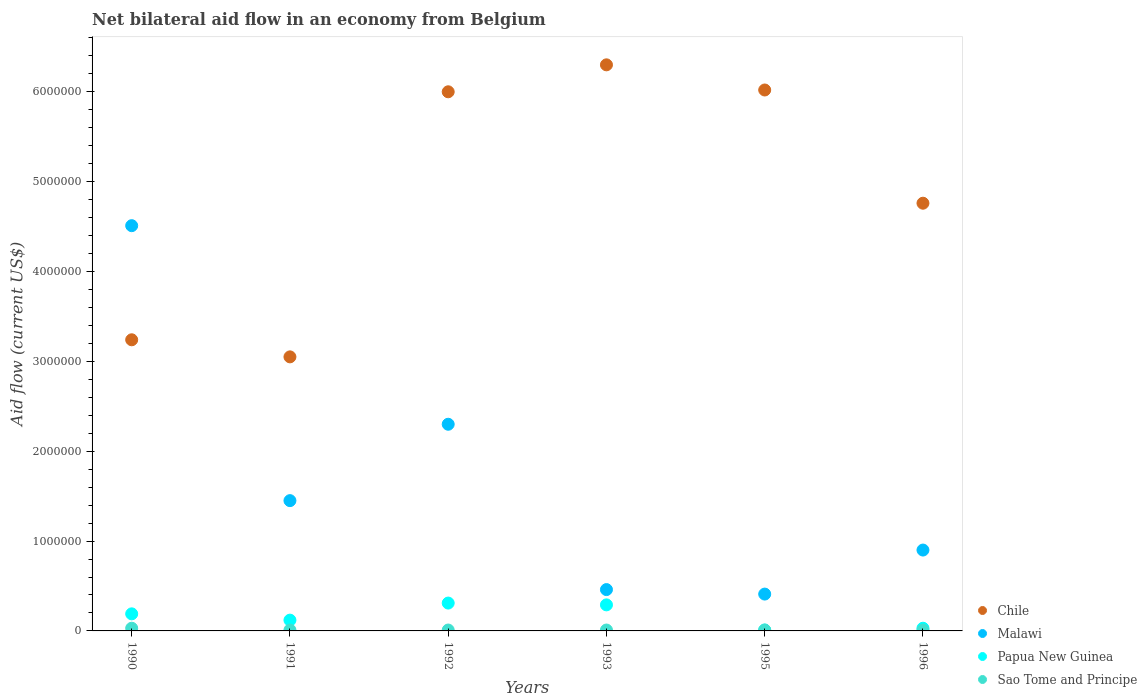Is the number of dotlines equal to the number of legend labels?
Provide a short and direct response. Yes. What is the net bilateral aid flow in Chile in 1996?
Make the answer very short. 4.76e+06. Across all years, what is the minimum net bilateral aid flow in Chile?
Your answer should be very brief. 3.05e+06. In which year was the net bilateral aid flow in Papua New Guinea minimum?
Make the answer very short. 1995. What is the total net bilateral aid flow in Malawi in the graph?
Make the answer very short. 1.00e+07. What is the difference between the net bilateral aid flow in Sao Tome and Principe in 1992 and the net bilateral aid flow in Papua New Guinea in 1995?
Your response must be concise. 0. What is the average net bilateral aid flow in Chile per year?
Your response must be concise. 4.90e+06. In the year 1992, what is the difference between the net bilateral aid flow in Papua New Guinea and net bilateral aid flow in Malawi?
Your answer should be compact. -1.99e+06. In how many years, is the net bilateral aid flow in Sao Tome and Principe greater than 400000 US$?
Offer a terse response. 0. What is the ratio of the net bilateral aid flow in Chile in 1991 to that in 1993?
Keep it short and to the point. 0.48. Is the difference between the net bilateral aid flow in Papua New Guinea in 1990 and 1995 greater than the difference between the net bilateral aid flow in Malawi in 1990 and 1995?
Keep it short and to the point. No. What is the difference between the highest and the second highest net bilateral aid flow in Sao Tome and Principe?
Ensure brevity in your answer.  2.00e+04. What is the difference between the highest and the lowest net bilateral aid flow in Chile?
Offer a terse response. 3.25e+06. Is the sum of the net bilateral aid flow in Malawi in 1995 and 1996 greater than the maximum net bilateral aid flow in Chile across all years?
Provide a succinct answer. No. Is it the case that in every year, the sum of the net bilateral aid flow in Sao Tome and Principe and net bilateral aid flow in Malawi  is greater than the net bilateral aid flow in Chile?
Make the answer very short. No. Does the net bilateral aid flow in Papua New Guinea monotonically increase over the years?
Your answer should be compact. No. Is the net bilateral aid flow in Malawi strictly less than the net bilateral aid flow in Chile over the years?
Provide a succinct answer. No. Are the values on the major ticks of Y-axis written in scientific E-notation?
Make the answer very short. No. Does the graph contain any zero values?
Keep it short and to the point. No. What is the title of the graph?
Provide a succinct answer. Net bilateral aid flow in an economy from Belgium. What is the label or title of the X-axis?
Provide a short and direct response. Years. What is the label or title of the Y-axis?
Give a very brief answer. Aid flow (current US$). What is the Aid flow (current US$) in Chile in 1990?
Your answer should be very brief. 3.24e+06. What is the Aid flow (current US$) of Malawi in 1990?
Make the answer very short. 4.51e+06. What is the Aid flow (current US$) of Papua New Guinea in 1990?
Give a very brief answer. 1.90e+05. What is the Aid flow (current US$) of Sao Tome and Principe in 1990?
Make the answer very short. 3.00e+04. What is the Aid flow (current US$) in Chile in 1991?
Your response must be concise. 3.05e+06. What is the Aid flow (current US$) of Malawi in 1991?
Your answer should be compact. 1.45e+06. What is the Aid flow (current US$) of Malawi in 1992?
Your response must be concise. 2.30e+06. What is the Aid flow (current US$) in Sao Tome and Principe in 1992?
Give a very brief answer. 10000. What is the Aid flow (current US$) in Chile in 1993?
Offer a very short reply. 6.30e+06. What is the Aid flow (current US$) of Malawi in 1993?
Your answer should be compact. 4.60e+05. What is the Aid flow (current US$) in Papua New Guinea in 1993?
Offer a very short reply. 2.90e+05. What is the Aid flow (current US$) in Sao Tome and Principe in 1993?
Ensure brevity in your answer.  10000. What is the Aid flow (current US$) in Chile in 1995?
Provide a short and direct response. 6.02e+06. What is the Aid flow (current US$) in Chile in 1996?
Your answer should be compact. 4.76e+06. What is the Aid flow (current US$) of Malawi in 1996?
Offer a terse response. 9.00e+05. What is the Aid flow (current US$) in Papua New Guinea in 1996?
Offer a very short reply. 3.00e+04. What is the Aid flow (current US$) in Sao Tome and Principe in 1996?
Your response must be concise. 10000. Across all years, what is the maximum Aid flow (current US$) in Chile?
Offer a terse response. 6.30e+06. Across all years, what is the maximum Aid flow (current US$) in Malawi?
Provide a succinct answer. 4.51e+06. Across all years, what is the maximum Aid flow (current US$) in Papua New Guinea?
Your answer should be very brief. 3.10e+05. Across all years, what is the maximum Aid flow (current US$) of Sao Tome and Principe?
Offer a terse response. 3.00e+04. Across all years, what is the minimum Aid flow (current US$) in Chile?
Your response must be concise. 3.05e+06. Across all years, what is the minimum Aid flow (current US$) in Malawi?
Make the answer very short. 4.10e+05. Across all years, what is the minimum Aid flow (current US$) in Papua New Guinea?
Give a very brief answer. 10000. Across all years, what is the minimum Aid flow (current US$) of Sao Tome and Principe?
Your response must be concise. 10000. What is the total Aid flow (current US$) in Chile in the graph?
Offer a terse response. 2.94e+07. What is the total Aid flow (current US$) of Malawi in the graph?
Your response must be concise. 1.00e+07. What is the total Aid flow (current US$) in Papua New Guinea in the graph?
Ensure brevity in your answer.  9.50e+05. What is the difference between the Aid flow (current US$) in Malawi in 1990 and that in 1991?
Provide a succinct answer. 3.06e+06. What is the difference between the Aid flow (current US$) in Chile in 1990 and that in 1992?
Your response must be concise. -2.76e+06. What is the difference between the Aid flow (current US$) in Malawi in 1990 and that in 1992?
Your response must be concise. 2.21e+06. What is the difference between the Aid flow (current US$) in Chile in 1990 and that in 1993?
Your answer should be compact. -3.06e+06. What is the difference between the Aid flow (current US$) in Malawi in 1990 and that in 1993?
Provide a short and direct response. 4.05e+06. What is the difference between the Aid flow (current US$) of Sao Tome and Principe in 1990 and that in 1993?
Make the answer very short. 2.00e+04. What is the difference between the Aid flow (current US$) of Chile in 1990 and that in 1995?
Your answer should be very brief. -2.78e+06. What is the difference between the Aid flow (current US$) of Malawi in 1990 and that in 1995?
Your response must be concise. 4.10e+06. What is the difference between the Aid flow (current US$) of Papua New Guinea in 1990 and that in 1995?
Your response must be concise. 1.80e+05. What is the difference between the Aid flow (current US$) in Sao Tome and Principe in 1990 and that in 1995?
Your answer should be very brief. 2.00e+04. What is the difference between the Aid flow (current US$) of Chile in 1990 and that in 1996?
Your answer should be compact. -1.52e+06. What is the difference between the Aid flow (current US$) in Malawi in 1990 and that in 1996?
Your answer should be compact. 3.61e+06. What is the difference between the Aid flow (current US$) in Papua New Guinea in 1990 and that in 1996?
Your response must be concise. 1.60e+05. What is the difference between the Aid flow (current US$) in Sao Tome and Principe in 1990 and that in 1996?
Offer a terse response. 2.00e+04. What is the difference between the Aid flow (current US$) in Chile in 1991 and that in 1992?
Offer a very short reply. -2.95e+06. What is the difference between the Aid flow (current US$) in Malawi in 1991 and that in 1992?
Offer a terse response. -8.50e+05. What is the difference between the Aid flow (current US$) in Papua New Guinea in 1991 and that in 1992?
Keep it short and to the point. -1.90e+05. What is the difference between the Aid flow (current US$) in Sao Tome and Principe in 1991 and that in 1992?
Make the answer very short. 0. What is the difference between the Aid flow (current US$) in Chile in 1991 and that in 1993?
Give a very brief answer. -3.25e+06. What is the difference between the Aid flow (current US$) in Malawi in 1991 and that in 1993?
Offer a terse response. 9.90e+05. What is the difference between the Aid flow (current US$) in Chile in 1991 and that in 1995?
Keep it short and to the point. -2.97e+06. What is the difference between the Aid flow (current US$) of Malawi in 1991 and that in 1995?
Provide a short and direct response. 1.04e+06. What is the difference between the Aid flow (current US$) of Papua New Guinea in 1991 and that in 1995?
Give a very brief answer. 1.10e+05. What is the difference between the Aid flow (current US$) in Sao Tome and Principe in 1991 and that in 1995?
Give a very brief answer. 0. What is the difference between the Aid flow (current US$) in Chile in 1991 and that in 1996?
Make the answer very short. -1.71e+06. What is the difference between the Aid flow (current US$) in Malawi in 1991 and that in 1996?
Make the answer very short. 5.50e+05. What is the difference between the Aid flow (current US$) of Papua New Guinea in 1991 and that in 1996?
Give a very brief answer. 9.00e+04. What is the difference between the Aid flow (current US$) of Sao Tome and Principe in 1991 and that in 1996?
Your answer should be compact. 0. What is the difference between the Aid flow (current US$) of Chile in 1992 and that in 1993?
Provide a short and direct response. -3.00e+05. What is the difference between the Aid flow (current US$) in Malawi in 1992 and that in 1993?
Offer a very short reply. 1.84e+06. What is the difference between the Aid flow (current US$) in Papua New Guinea in 1992 and that in 1993?
Offer a terse response. 2.00e+04. What is the difference between the Aid flow (current US$) of Sao Tome and Principe in 1992 and that in 1993?
Give a very brief answer. 0. What is the difference between the Aid flow (current US$) of Malawi in 1992 and that in 1995?
Give a very brief answer. 1.89e+06. What is the difference between the Aid flow (current US$) of Sao Tome and Principe in 1992 and that in 1995?
Your answer should be very brief. 0. What is the difference between the Aid flow (current US$) in Chile in 1992 and that in 1996?
Offer a very short reply. 1.24e+06. What is the difference between the Aid flow (current US$) of Malawi in 1992 and that in 1996?
Provide a succinct answer. 1.40e+06. What is the difference between the Aid flow (current US$) in Sao Tome and Principe in 1992 and that in 1996?
Keep it short and to the point. 0. What is the difference between the Aid flow (current US$) in Chile in 1993 and that in 1996?
Your answer should be compact. 1.54e+06. What is the difference between the Aid flow (current US$) in Malawi in 1993 and that in 1996?
Offer a very short reply. -4.40e+05. What is the difference between the Aid flow (current US$) in Chile in 1995 and that in 1996?
Provide a short and direct response. 1.26e+06. What is the difference between the Aid flow (current US$) of Malawi in 1995 and that in 1996?
Give a very brief answer. -4.90e+05. What is the difference between the Aid flow (current US$) of Sao Tome and Principe in 1995 and that in 1996?
Keep it short and to the point. 0. What is the difference between the Aid flow (current US$) in Chile in 1990 and the Aid flow (current US$) in Malawi in 1991?
Make the answer very short. 1.79e+06. What is the difference between the Aid flow (current US$) in Chile in 1990 and the Aid flow (current US$) in Papua New Guinea in 1991?
Make the answer very short. 3.12e+06. What is the difference between the Aid flow (current US$) in Chile in 1990 and the Aid flow (current US$) in Sao Tome and Principe in 1991?
Offer a terse response. 3.23e+06. What is the difference between the Aid flow (current US$) of Malawi in 1990 and the Aid flow (current US$) of Papua New Guinea in 1991?
Offer a very short reply. 4.39e+06. What is the difference between the Aid flow (current US$) in Malawi in 1990 and the Aid flow (current US$) in Sao Tome and Principe in 1991?
Give a very brief answer. 4.50e+06. What is the difference between the Aid flow (current US$) in Chile in 1990 and the Aid flow (current US$) in Malawi in 1992?
Offer a terse response. 9.40e+05. What is the difference between the Aid flow (current US$) in Chile in 1990 and the Aid flow (current US$) in Papua New Guinea in 1992?
Make the answer very short. 2.93e+06. What is the difference between the Aid flow (current US$) in Chile in 1990 and the Aid flow (current US$) in Sao Tome and Principe in 1992?
Provide a succinct answer. 3.23e+06. What is the difference between the Aid flow (current US$) in Malawi in 1990 and the Aid flow (current US$) in Papua New Guinea in 1992?
Provide a short and direct response. 4.20e+06. What is the difference between the Aid flow (current US$) in Malawi in 1990 and the Aid flow (current US$) in Sao Tome and Principe in 1992?
Ensure brevity in your answer.  4.50e+06. What is the difference between the Aid flow (current US$) of Papua New Guinea in 1990 and the Aid flow (current US$) of Sao Tome and Principe in 1992?
Provide a short and direct response. 1.80e+05. What is the difference between the Aid flow (current US$) in Chile in 1990 and the Aid flow (current US$) in Malawi in 1993?
Offer a very short reply. 2.78e+06. What is the difference between the Aid flow (current US$) of Chile in 1990 and the Aid flow (current US$) of Papua New Guinea in 1993?
Offer a terse response. 2.95e+06. What is the difference between the Aid flow (current US$) of Chile in 1990 and the Aid flow (current US$) of Sao Tome and Principe in 1993?
Keep it short and to the point. 3.23e+06. What is the difference between the Aid flow (current US$) in Malawi in 1990 and the Aid flow (current US$) in Papua New Guinea in 1993?
Your answer should be very brief. 4.22e+06. What is the difference between the Aid flow (current US$) in Malawi in 1990 and the Aid flow (current US$) in Sao Tome and Principe in 1993?
Your answer should be very brief. 4.50e+06. What is the difference between the Aid flow (current US$) of Papua New Guinea in 1990 and the Aid flow (current US$) of Sao Tome and Principe in 1993?
Ensure brevity in your answer.  1.80e+05. What is the difference between the Aid flow (current US$) of Chile in 1990 and the Aid flow (current US$) of Malawi in 1995?
Your response must be concise. 2.83e+06. What is the difference between the Aid flow (current US$) of Chile in 1990 and the Aid flow (current US$) of Papua New Guinea in 1995?
Make the answer very short. 3.23e+06. What is the difference between the Aid flow (current US$) of Chile in 1990 and the Aid flow (current US$) of Sao Tome and Principe in 1995?
Make the answer very short. 3.23e+06. What is the difference between the Aid flow (current US$) of Malawi in 1990 and the Aid flow (current US$) of Papua New Guinea in 1995?
Ensure brevity in your answer.  4.50e+06. What is the difference between the Aid flow (current US$) of Malawi in 1990 and the Aid flow (current US$) of Sao Tome and Principe in 1995?
Keep it short and to the point. 4.50e+06. What is the difference between the Aid flow (current US$) of Papua New Guinea in 1990 and the Aid flow (current US$) of Sao Tome and Principe in 1995?
Give a very brief answer. 1.80e+05. What is the difference between the Aid flow (current US$) of Chile in 1990 and the Aid flow (current US$) of Malawi in 1996?
Give a very brief answer. 2.34e+06. What is the difference between the Aid flow (current US$) of Chile in 1990 and the Aid flow (current US$) of Papua New Guinea in 1996?
Offer a very short reply. 3.21e+06. What is the difference between the Aid flow (current US$) in Chile in 1990 and the Aid flow (current US$) in Sao Tome and Principe in 1996?
Keep it short and to the point. 3.23e+06. What is the difference between the Aid flow (current US$) in Malawi in 1990 and the Aid flow (current US$) in Papua New Guinea in 1996?
Keep it short and to the point. 4.48e+06. What is the difference between the Aid flow (current US$) of Malawi in 1990 and the Aid flow (current US$) of Sao Tome and Principe in 1996?
Make the answer very short. 4.50e+06. What is the difference between the Aid flow (current US$) of Papua New Guinea in 1990 and the Aid flow (current US$) of Sao Tome and Principe in 1996?
Your answer should be compact. 1.80e+05. What is the difference between the Aid flow (current US$) of Chile in 1991 and the Aid flow (current US$) of Malawi in 1992?
Keep it short and to the point. 7.50e+05. What is the difference between the Aid flow (current US$) of Chile in 1991 and the Aid flow (current US$) of Papua New Guinea in 1992?
Your answer should be compact. 2.74e+06. What is the difference between the Aid flow (current US$) of Chile in 1991 and the Aid flow (current US$) of Sao Tome and Principe in 1992?
Your response must be concise. 3.04e+06. What is the difference between the Aid flow (current US$) of Malawi in 1991 and the Aid flow (current US$) of Papua New Guinea in 1992?
Your answer should be compact. 1.14e+06. What is the difference between the Aid flow (current US$) in Malawi in 1991 and the Aid flow (current US$) in Sao Tome and Principe in 1992?
Offer a very short reply. 1.44e+06. What is the difference between the Aid flow (current US$) of Chile in 1991 and the Aid flow (current US$) of Malawi in 1993?
Ensure brevity in your answer.  2.59e+06. What is the difference between the Aid flow (current US$) in Chile in 1991 and the Aid flow (current US$) in Papua New Guinea in 1993?
Your response must be concise. 2.76e+06. What is the difference between the Aid flow (current US$) of Chile in 1991 and the Aid flow (current US$) of Sao Tome and Principe in 1993?
Keep it short and to the point. 3.04e+06. What is the difference between the Aid flow (current US$) in Malawi in 1991 and the Aid flow (current US$) in Papua New Guinea in 1993?
Provide a short and direct response. 1.16e+06. What is the difference between the Aid flow (current US$) of Malawi in 1991 and the Aid flow (current US$) of Sao Tome and Principe in 1993?
Provide a succinct answer. 1.44e+06. What is the difference between the Aid flow (current US$) of Chile in 1991 and the Aid flow (current US$) of Malawi in 1995?
Ensure brevity in your answer.  2.64e+06. What is the difference between the Aid flow (current US$) of Chile in 1991 and the Aid flow (current US$) of Papua New Guinea in 1995?
Offer a terse response. 3.04e+06. What is the difference between the Aid flow (current US$) in Chile in 1991 and the Aid flow (current US$) in Sao Tome and Principe in 1995?
Offer a terse response. 3.04e+06. What is the difference between the Aid flow (current US$) in Malawi in 1991 and the Aid flow (current US$) in Papua New Guinea in 1995?
Give a very brief answer. 1.44e+06. What is the difference between the Aid flow (current US$) of Malawi in 1991 and the Aid flow (current US$) of Sao Tome and Principe in 1995?
Your answer should be compact. 1.44e+06. What is the difference between the Aid flow (current US$) in Papua New Guinea in 1991 and the Aid flow (current US$) in Sao Tome and Principe in 1995?
Ensure brevity in your answer.  1.10e+05. What is the difference between the Aid flow (current US$) in Chile in 1991 and the Aid flow (current US$) in Malawi in 1996?
Offer a terse response. 2.15e+06. What is the difference between the Aid flow (current US$) in Chile in 1991 and the Aid flow (current US$) in Papua New Guinea in 1996?
Offer a terse response. 3.02e+06. What is the difference between the Aid flow (current US$) in Chile in 1991 and the Aid flow (current US$) in Sao Tome and Principe in 1996?
Offer a very short reply. 3.04e+06. What is the difference between the Aid flow (current US$) of Malawi in 1991 and the Aid flow (current US$) of Papua New Guinea in 1996?
Your response must be concise. 1.42e+06. What is the difference between the Aid flow (current US$) in Malawi in 1991 and the Aid flow (current US$) in Sao Tome and Principe in 1996?
Your answer should be compact. 1.44e+06. What is the difference between the Aid flow (current US$) in Papua New Guinea in 1991 and the Aid flow (current US$) in Sao Tome and Principe in 1996?
Provide a succinct answer. 1.10e+05. What is the difference between the Aid flow (current US$) in Chile in 1992 and the Aid flow (current US$) in Malawi in 1993?
Give a very brief answer. 5.54e+06. What is the difference between the Aid flow (current US$) of Chile in 1992 and the Aid flow (current US$) of Papua New Guinea in 1993?
Make the answer very short. 5.71e+06. What is the difference between the Aid flow (current US$) in Chile in 1992 and the Aid flow (current US$) in Sao Tome and Principe in 1993?
Give a very brief answer. 5.99e+06. What is the difference between the Aid flow (current US$) of Malawi in 1992 and the Aid flow (current US$) of Papua New Guinea in 1993?
Your answer should be very brief. 2.01e+06. What is the difference between the Aid flow (current US$) of Malawi in 1992 and the Aid flow (current US$) of Sao Tome and Principe in 1993?
Your answer should be very brief. 2.29e+06. What is the difference between the Aid flow (current US$) in Chile in 1992 and the Aid flow (current US$) in Malawi in 1995?
Your answer should be very brief. 5.59e+06. What is the difference between the Aid flow (current US$) of Chile in 1992 and the Aid flow (current US$) of Papua New Guinea in 1995?
Your answer should be compact. 5.99e+06. What is the difference between the Aid flow (current US$) of Chile in 1992 and the Aid flow (current US$) of Sao Tome and Principe in 1995?
Offer a terse response. 5.99e+06. What is the difference between the Aid flow (current US$) of Malawi in 1992 and the Aid flow (current US$) of Papua New Guinea in 1995?
Ensure brevity in your answer.  2.29e+06. What is the difference between the Aid flow (current US$) in Malawi in 1992 and the Aid flow (current US$) in Sao Tome and Principe in 1995?
Make the answer very short. 2.29e+06. What is the difference between the Aid flow (current US$) in Papua New Guinea in 1992 and the Aid flow (current US$) in Sao Tome and Principe in 1995?
Offer a terse response. 3.00e+05. What is the difference between the Aid flow (current US$) in Chile in 1992 and the Aid flow (current US$) in Malawi in 1996?
Provide a succinct answer. 5.10e+06. What is the difference between the Aid flow (current US$) in Chile in 1992 and the Aid flow (current US$) in Papua New Guinea in 1996?
Keep it short and to the point. 5.97e+06. What is the difference between the Aid flow (current US$) of Chile in 1992 and the Aid flow (current US$) of Sao Tome and Principe in 1996?
Give a very brief answer. 5.99e+06. What is the difference between the Aid flow (current US$) of Malawi in 1992 and the Aid flow (current US$) of Papua New Guinea in 1996?
Make the answer very short. 2.27e+06. What is the difference between the Aid flow (current US$) in Malawi in 1992 and the Aid flow (current US$) in Sao Tome and Principe in 1996?
Your answer should be compact. 2.29e+06. What is the difference between the Aid flow (current US$) in Chile in 1993 and the Aid flow (current US$) in Malawi in 1995?
Offer a terse response. 5.89e+06. What is the difference between the Aid flow (current US$) in Chile in 1993 and the Aid flow (current US$) in Papua New Guinea in 1995?
Make the answer very short. 6.29e+06. What is the difference between the Aid flow (current US$) of Chile in 1993 and the Aid flow (current US$) of Sao Tome and Principe in 1995?
Ensure brevity in your answer.  6.29e+06. What is the difference between the Aid flow (current US$) of Papua New Guinea in 1993 and the Aid flow (current US$) of Sao Tome and Principe in 1995?
Your response must be concise. 2.80e+05. What is the difference between the Aid flow (current US$) in Chile in 1993 and the Aid flow (current US$) in Malawi in 1996?
Make the answer very short. 5.40e+06. What is the difference between the Aid flow (current US$) in Chile in 1993 and the Aid flow (current US$) in Papua New Guinea in 1996?
Give a very brief answer. 6.27e+06. What is the difference between the Aid flow (current US$) in Chile in 1993 and the Aid flow (current US$) in Sao Tome and Principe in 1996?
Ensure brevity in your answer.  6.29e+06. What is the difference between the Aid flow (current US$) in Malawi in 1993 and the Aid flow (current US$) in Papua New Guinea in 1996?
Keep it short and to the point. 4.30e+05. What is the difference between the Aid flow (current US$) in Malawi in 1993 and the Aid flow (current US$) in Sao Tome and Principe in 1996?
Ensure brevity in your answer.  4.50e+05. What is the difference between the Aid flow (current US$) of Papua New Guinea in 1993 and the Aid flow (current US$) of Sao Tome and Principe in 1996?
Your response must be concise. 2.80e+05. What is the difference between the Aid flow (current US$) of Chile in 1995 and the Aid flow (current US$) of Malawi in 1996?
Ensure brevity in your answer.  5.12e+06. What is the difference between the Aid flow (current US$) of Chile in 1995 and the Aid flow (current US$) of Papua New Guinea in 1996?
Ensure brevity in your answer.  5.99e+06. What is the difference between the Aid flow (current US$) of Chile in 1995 and the Aid flow (current US$) of Sao Tome and Principe in 1996?
Your answer should be very brief. 6.01e+06. What is the difference between the Aid flow (current US$) of Malawi in 1995 and the Aid flow (current US$) of Papua New Guinea in 1996?
Give a very brief answer. 3.80e+05. What is the difference between the Aid flow (current US$) of Malawi in 1995 and the Aid flow (current US$) of Sao Tome and Principe in 1996?
Offer a very short reply. 4.00e+05. What is the difference between the Aid flow (current US$) of Papua New Guinea in 1995 and the Aid flow (current US$) of Sao Tome and Principe in 1996?
Offer a very short reply. 0. What is the average Aid flow (current US$) of Chile per year?
Offer a very short reply. 4.90e+06. What is the average Aid flow (current US$) in Malawi per year?
Provide a succinct answer. 1.67e+06. What is the average Aid flow (current US$) in Papua New Guinea per year?
Give a very brief answer. 1.58e+05. What is the average Aid flow (current US$) of Sao Tome and Principe per year?
Offer a terse response. 1.33e+04. In the year 1990, what is the difference between the Aid flow (current US$) of Chile and Aid flow (current US$) of Malawi?
Your answer should be very brief. -1.27e+06. In the year 1990, what is the difference between the Aid flow (current US$) of Chile and Aid flow (current US$) of Papua New Guinea?
Provide a short and direct response. 3.05e+06. In the year 1990, what is the difference between the Aid flow (current US$) in Chile and Aid flow (current US$) in Sao Tome and Principe?
Give a very brief answer. 3.21e+06. In the year 1990, what is the difference between the Aid flow (current US$) of Malawi and Aid flow (current US$) of Papua New Guinea?
Make the answer very short. 4.32e+06. In the year 1990, what is the difference between the Aid flow (current US$) in Malawi and Aid flow (current US$) in Sao Tome and Principe?
Offer a very short reply. 4.48e+06. In the year 1990, what is the difference between the Aid flow (current US$) of Papua New Guinea and Aid flow (current US$) of Sao Tome and Principe?
Provide a succinct answer. 1.60e+05. In the year 1991, what is the difference between the Aid flow (current US$) in Chile and Aid flow (current US$) in Malawi?
Your answer should be very brief. 1.60e+06. In the year 1991, what is the difference between the Aid flow (current US$) in Chile and Aid flow (current US$) in Papua New Guinea?
Your answer should be compact. 2.93e+06. In the year 1991, what is the difference between the Aid flow (current US$) of Chile and Aid flow (current US$) of Sao Tome and Principe?
Keep it short and to the point. 3.04e+06. In the year 1991, what is the difference between the Aid flow (current US$) of Malawi and Aid flow (current US$) of Papua New Guinea?
Ensure brevity in your answer.  1.33e+06. In the year 1991, what is the difference between the Aid flow (current US$) of Malawi and Aid flow (current US$) of Sao Tome and Principe?
Offer a terse response. 1.44e+06. In the year 1991, what is the difference between the Aid flow (current US$) of Papua New Guinea and Aid flow (current US$) of Sao Tome and Principe?
Your answer should be compact. 1.10e+05. In the year 1992, what is the difference between the Aid flow (current US$) in Chile and Aid flow (current US$) in Malawi?
Provide a succinct answer. 3.70e+06. In the year 1992, what is the difference between the Aid flow (current US$) in Chile and Aid flow (current US$) in Papua New Guinea?
Provide a short and direct response. 5.69e+06. In the year 1992, what is the difference between the Aid flow (current US$) in Chile and Aid flow (current US$) in Sao Tome and Principe?
Your answer should be very brief. 5.99e+06. In the year 1992, what is the difference between the Aid flow (current US$) of Malawi and Aid flow (current US$) of Papua New Guinea?
Your answer should be compact. 1.99e+06. In the year 1992, what is the difference between the Aid flow (current US$) in Malawi and Aid flow (current US$) in Sao Tome and Principe?
Provide a succinct answer. 2.29e+06. In the year 1992, what is the difference between the Aid flow (current US$) of Papua New Guinea and Aid flow (current US$) of Sao Tome and Principe?
Your answer should be compact. 3.00e+05. In the year 1993, what is the difference between the Aid flow (current US$) of Chile and Aid flow (current US$) of Malawi?
Provide a short and direct response. 5.84e+06. In the year 1993, what is the difference between the Aid flow (current US$) in Chile and Aid flow (current US$) in Papua New Guinea?
Offer a very short reply. 6.01e+06. In the year 1993, what is the difference between the Aid flow (current US$) of Chile and Aid flow (current US$) of Sao Tome and Principe?
Provide a short and direct response. 6.29e+06. In the year 1993, what is the difference between the Aid flow (current US$) of Papua New Guinea and Aid flow (current US$) of Sao Tome and Principe?
Make the answer very short. 2.80e+05. In the year 1995, what is the difference between the Aid flow (current US$) in Chile and Aid flow (current US$) in Malawi?
Offer a terse response. 5.61e+06. In the year 1995, what is the difference between the Aid flow (current US$) of Chile and Aid flow (current US$) of Papua New Guinea?
Provide a succinct answer. 6.01e+06. In the year 1995, what is the difference between the Aid flow (current US$) of Chile and Aid flow (current US$) of Sao Tome and Principe?
Your answer should be compact. 6.01e+06. In the year 1995, what is the difference between the Aid flow (current US$) in Malawi and Aid flow (current US$) in Papua New Guinea?
Ensure brevity in your answer.  4.00e+05. In the year 1995, what is the difference between the Aid flow (current US$) in Malawi and Aid flow (current US$) in Sao Tome and Principe?
Offer a terse response. 4.00e+05. In the year 1996, what is the difference between the Aid flow (current US$) of Chile and Aid flow (current US$) of Malawi?
Keep it short and to the point. 3.86e+06. In the year 1996, what is the difference between the Aid flow (current US$) of Chile and Aid flow (current US$) of Papua New Guinea?
Give a very brief answer. 4.73e+06. In the year 1996, what is the difference between the Aid flow (current US$) in Chile and Aid flow (current US$) in Sao Tome and Principe?
Your answer should be very brief. 4.75e+06. In the year 1996, what is the difference between the Aid flow (current US$) of Malawi and Aid flow (current US$) of Papua New Guinea?
Give a very brief answer. 8.70e+05. In the year 1996, what is the difference between the Aid flow (current US$) of Malawi and Aid flow (current US$) of Sao Tome and Principe?
Your answer should be very brief. 8.90e+05. What is the ratio of the Aid flow (current US$) in Chile in 1990 to that in 1991?
Your response must be concise. 1.06. What is the ratio of the Aid flow (current US$) of Malawi in 1990 to that in 1991?
Your answer should be very brief. 3.11. What is the ratio of the Aid flow (current US$) in Papua New Guinea in 1990 to that in 1991?
Offer a very short reply. 1.58. What is the ratio of the Aid flow (current US$) in Sao Tome and Principe in 1990 to that in 1991?
Provide a succinct answer. 3. What is the ratio of the Aid flow (current US$) in Chile in 1990 to that in 1992?
Offer a very short reply. 0.54. What is the ratio of the Aid flow (current US$) in Malawi in 1990 to that in 1992?
Keep it short and to the point. 1.96. What is the ratio of the Aid flow (current US$) of Papua New Guinea in 1990 to that in 1992?
Your answer should be compact. 0.61. What is the ratio of the Aid flow (current US$) of Sao Tome and Principe in 1990 to that in 1992?
Your response must be concise. 3. What is the ratio of the Aid flow (current US$) of Chile in 1990 to that in 1993?
Offer a terse response. 0.51. What is the ratio of the Aid flow (current US$) in Malawi in 1990 to that in 1993?
Your response must be concise. 9.8. What is the ratio of the Aid flow (current US$) in Papua New Guinea in 1990 to that in 1993?
Ensure brevity in your answer.  0.66. What is the ratio of the Aid flow (current US$) of Sao Tome and Principe in 1990 to that in 1993?
Keep it short and to the point. 3. What is the ratio of the Aid flow (current US$) of Chile in 1990 to that in 1995?
Provide a short and direct response. 0.54. What is the ratio of the Aid flow (current US$) in Malawi in 1990 to that in 1995?
Offer a very short reply. 11. What is the ratio of the Aid flow (current US$) in Papua New Guinea in 1990 to that in 1995?
Provide a short and direct response. 19. What is the ratio of the Aid flow (current US$) of Chile in 1990 to that in 1996?
Provide a short and direct response. 0.68. What is the ratio of the Aid flow (current US$) in Malawi in 1990 to that in 1996?
Offer a very short reply. 5.01. What is the ratio of the Aid flow (current US$) of Papua New Guinea in 1990 to that in 1996?
Offer a very short reply. 6.33. What is the ratio of the Aid flow (current US$) in Sao Tome and Principe in 1990 to that in 1996?
Provide a short and direct response. 3. What is the ratio of the Aid flow (current US$) in Chile in 1991 to that in 1992?
Your response must be concise. 0.51. What is the ratio of the Aid flow (current US$) in Malawi in 1991 to that in 1992?
Provide a short and direct response. 0.63. What is the ratio of the Aid flow (current US$) in Papua New Guinea in 1991 to that in 1992?
Ensure brevity in your answer.  0.39. What is the ratio of the Aid flow (current US$) of Sao Tome and Principe in 1991 to that in 1992?
Your response must be concise. 1. What is the ratio of the Aid flow (current US$) of Chile in 1991 to that in 1993?
Make the answer very short. 0.48. What is the ratio of the Aid flow (current US$) in Malawi in 1991 to that in 1993?
Provide a succinct answer. 3.15. What is the ratio of the Aid flow (current US$) of Papua New Guinea in 1991 to that in 1993?
Give a very brief answer. 0.41. What is the ratio of the Aid flow (current US$) in Sao Tome and Principe in 1991 to that in 1993?
Offer a very short reply. 1. What is the ratio of the Aid flow (current US$) in Chile in 1991 to that in 1995?
Your response must be concise. 0.51. What is the ratio of the Aid flow (current US$) in Malawi in 1991 to that in 1995?
Your response must be concise. 3.54. What is the ratio of the Aid flow (current US$) of Sao Tome and Principe in 1991 to that in 1995?
Make the answer very short. 1. What is the ratio of the Aid flow (current US$) in Chile in 1991 to that in 1996?
Offer a very short reply. 0.64. What is the ratio of the Aid flow (current US$) in Malawi in 1991 to that in 1996?
Give a very brief answer. 1.61. What is the ratio of the Aid flow (current US$) in Malawi in 1992 to that in 1993?
Your answer should be very brief. 5. What is the ratio of the Aid flow (current US$) of Papua New Guinea in 1992 to that in 1993?
Your answer should be very brief. 1.07. What is the ratio of the Aid flow (current US$) in Malawi in 1992 to that in 1995?
Make the answer very short. 5.61. What is the ratio of the Aid flow (current US$) in Papua New Guinea in 1992 to that in 1995?
Provide a succinct answer. 31. What is the ratio of the Aid flow (current US$) of Chile in 1992 to that in 1996?
Provide a short and direct response. 1.26. What is the ratio of the Aid flow (current US$) of Malawi in 1992 to that in 1996?
Keep it short and to the point. 2.56. What is the ratio of the Aid flow (current US$) of Papua New Guinea in 1992 to that in 1996?
Provide a short and direct response. 10.33. What is the ratio of the Aid flow (current US$) of Chile in 1993 to that in 1995?
Give a very brief answer. 1.05. What is the ratio of the Aid flow (current US$) in Malawi in 1993 to that in 1995?
Make the answer very short. 1.12. What is the ratio of the Aid flow (current US$) of Chile in 1993 to that in 1996?
Your answer should be very brief. 1.32. What is the ratio of the Aid flow (current US$) of Malawi in 1993 to that in 1996?
Offer a very short reply. 0.51. What is the ratio of the Aid flow (current US$) of Papua New Guinea in 1993 to that in 1996?
Your answer should be compact. 9.67. What is the ratio of the Aid flow (current US$) of Sao Tome and Principe in 1993 to that in 1996?
Provide a short and direct response. 1. What is the ratio of the Aid flow (current US$) of Chile in 1995 to that in 1996?
Offer a terse response. 1.26. What is the ratio of the Aid flow (current US$) in Malawi in 1995 to that in 1996?
Offer a very short reply. 0.46. What is the ratio of the Aid flow (current US$) in Papua New Guinea in 1995 to that in 1996?
Give a very brief answer. 0.33. What is the difference between the highest and the second highest Aid flow (current US$) in Chile?
Keep it short and to the point. 2.80e+05. What is the difference between the highest and the second highest Aid flow (current US$) in Malawi?
Your response must be concise. 2.21e+06. What is the difference between the highest and the second highest Aid flow (current US$) in Sao Tome and Principe?
Ensure brevity in your answer.  2.00e+04. What is the difference between the highest and the lowest Aid flow (current US$) in Chile?
Offer a very short reply. 3.25e+06. What is the difference between the highest and the lowest Aid flow (current US$) in Malawi?
Make the answer very short. 4.10e+06. 